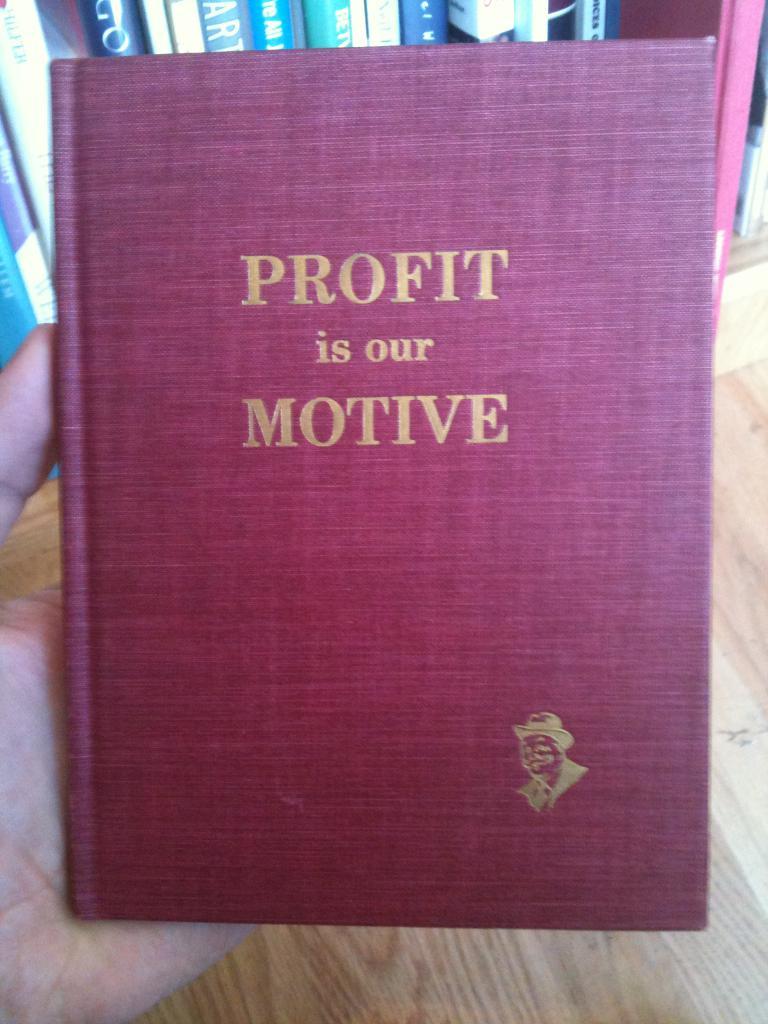What is the name of this book?
Your response must be concise. Profit is our motive. What are the two words in the middle?
Offer a terse response. Is our. 